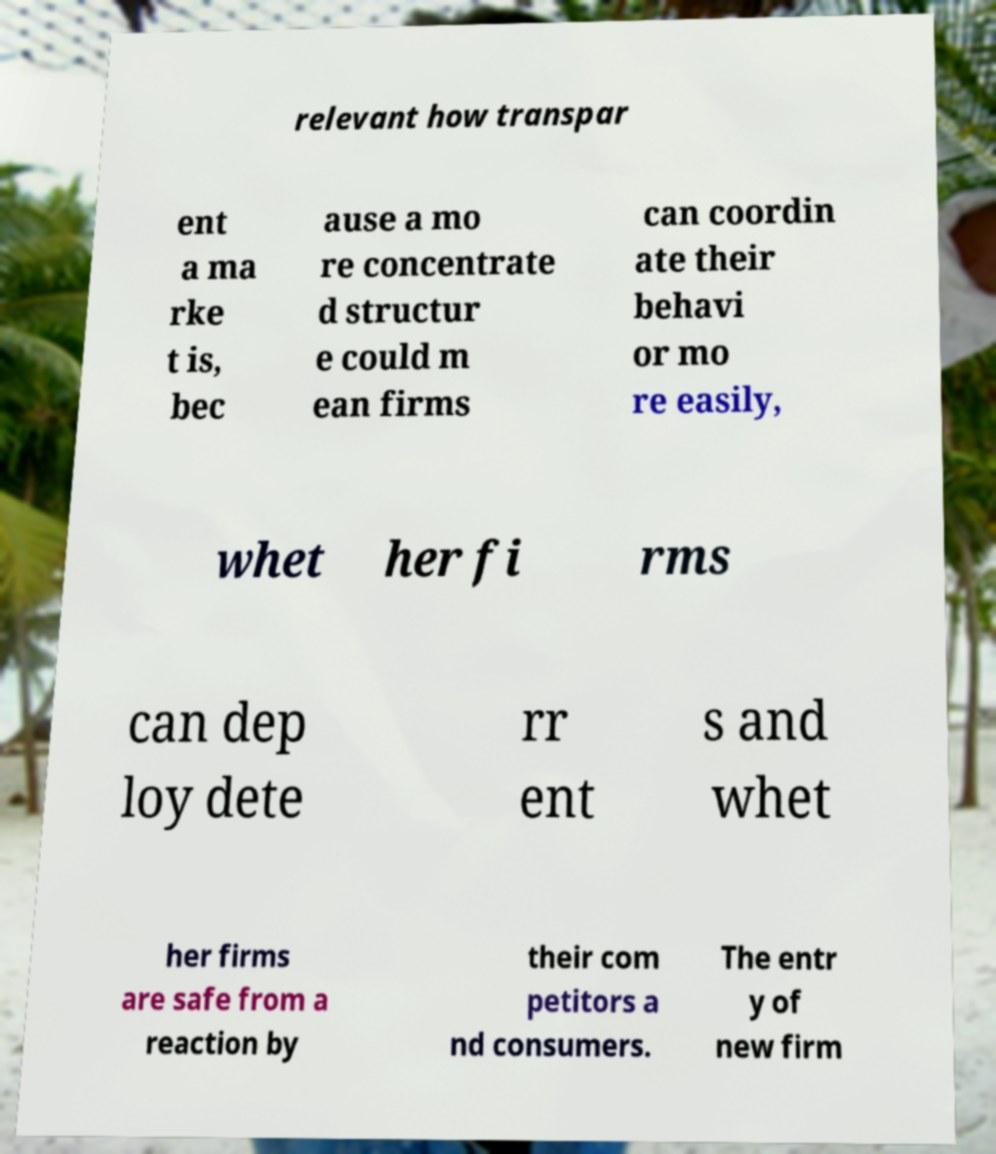What messages or text are displayed in this image? I need them in a readable, typed format. relevant how transpar ent a ma rke t is, bec ause a mo re concentrate d structur e could m ean firms can coordin ate their behavi or mo re easily, whet her fi rms can dep loy dete rr ent s and whet her firms are safe from a reaction by their com petitors a nd consumers. The entr y of new firm 